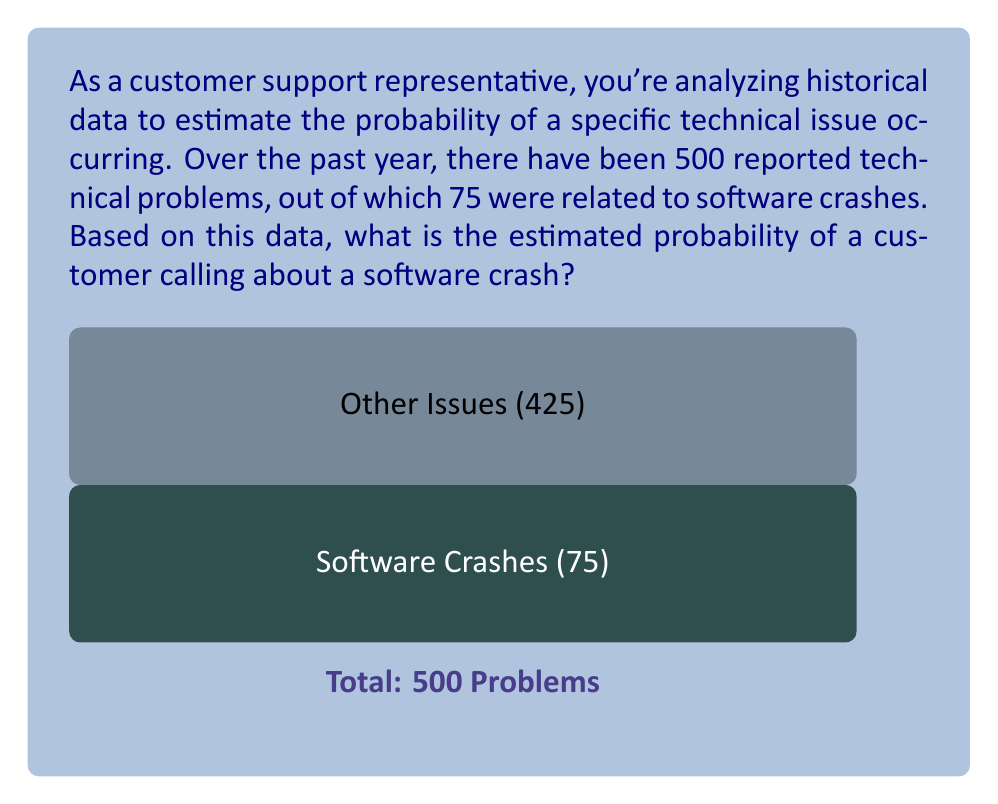Show me your answer to this math problem. To estimate the probability of a software crash occurring based on the given historical data, we need to use the concept of relative frequency as an estimate of probability.

Step 1: Identify the total number of events (total reported technical problems) and the number of favorable outcomes (software crashes).
Total events: $n = 500$
Favorable outcomes: $k = 75$

Step 2: Calculate the relative frequency using the formula:

$$ P(\text{software crash}) \approx \frac{\text{number of software crashes}}{\text{total number of technical problems}} $$

$$ P(\text{software crash}) \approx \frac{k}{n} = \frac{75}{500} $$

Step 3: Simplify the fraction:

$$ P(\text{software crash}) \approx \frac{75}{500} = \frac{3}{20} = 0.15 $$

Step 4: Convert to a percentage (optional):

$$ P(\text{software crash}) \approx 0.15 \times 100\% = 15\% $$

Therefore, based on the historical data, the estimated probability of a customer calling about a software crash is 0.15 or 15%.
Answer: $0.15$ or $15\%$ 